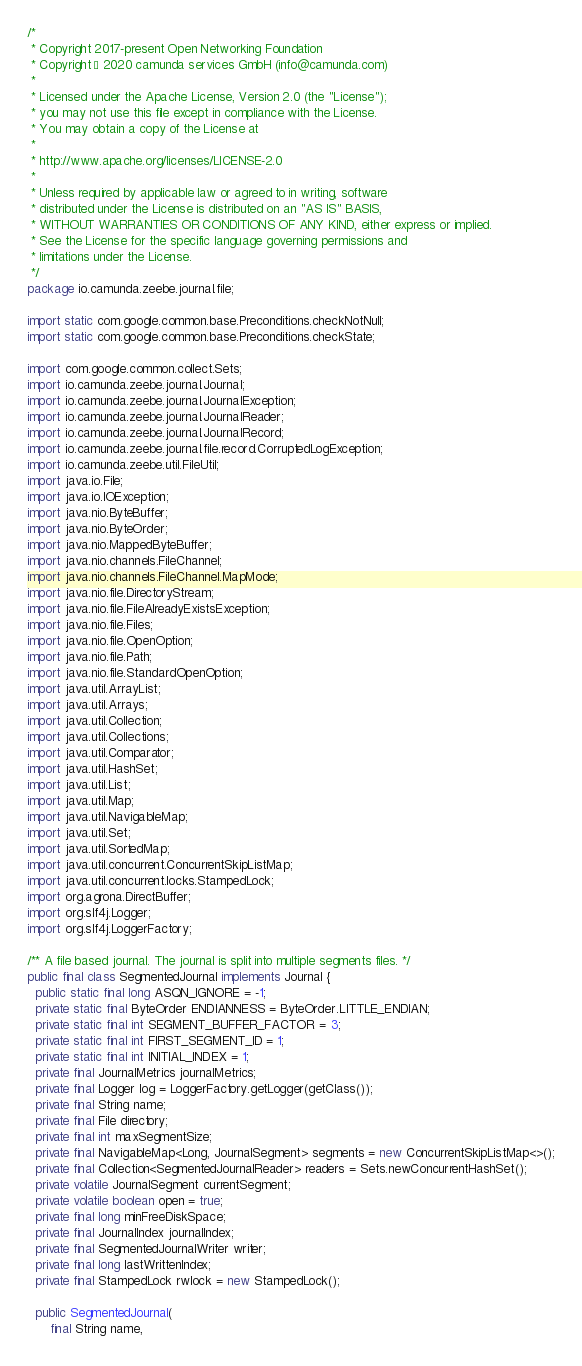<code> <loc_0><loc_0><loc_500><loc_500><_Java_>/*
 * Copyright 2017-present Open Networking Foundation
 * Copyright © 2020 camunda services GmbH (info@camunda.com)
 *
 * Licensed under the Apache License, Version 2.0 (the "License");
 * you may not use this file except in compliance with the License.
 * You may obtain a copy of the License at
 *
 * http://www.apache.org/licenses/LICENSE-2.0
 *
 * Unless required by applicable law or agreed to in writing, software
 * distributed under the License is distributed on an "AS IS" BASIS,
 * WITHOUT WARRANTIES OR CONDITIONS OF ANY KIND, either express or implied.
 * See the License for the specific language governing permissions and
 * limitations under the License.
 */
package io.camunda.zeebe.journal.file;

import static com.google.common.base.Preconditions.checkNotNull;
import static com.google.common.base.Preconditions.checkState;

import com.google.common.collect.Sets;
import io.camunda.zeebe.journal.Journal;
import io.camunda.zeebe.journal.JournalException;
import io.camunda.zeebe.journal.JournalReader;
import io.camunda.zeebe.journal.JournalRecord;
import io.camunda.zeebe.journal.file.record.CorruptedLogException;
import io.camunda.zeebe.util.FileUtil;
import java.io.File;
import java.io.IOException;
import java.nio.ByteBuffer;
import java.nio.ByteOrder;
import java.nio.MappedByteBuffer;
import java.nio.channels.FileChannel;
import java.nio.channels.FileChannel.MapMode;
import java.nio.file.DirectoryStream;
import java.nio.file.FileAlreadyExistsException;
import java.nio.file.Files;
import java.nio.file.OpenOption;
import java.nio.file.Path;
import java.nio.file.StandardOpenOption;
import java.util.ArrayList;
import java.util.Arrays;
import java.util.Collection;
import java.util.Collections;
import java.util.Comparator;
import java.util.HashSet;
import java.util.List;
import java.util.Map;
import java.util.NavigableMap;
import java.util.Set;
import java.util.SortedMap;
import java.util.concurrent.ConcurrentSkipListMap;
import java.util.concurrent.locks.StampedLock;
import org.agrona.DirectBuffer;
import org.slf4j.Logger;
import org.slf4j.LoggerFactory;

/** A file based journal. The journal is split into multiple segments files. */
public final class SegmentedJournal implements Journal {
  public static final long ASQN_IGNORE = -1;
  private static final ByteOrder ENDIANNESS = ByteOrder.LITTLE_ENDIAN;
  private static final int SEGMENT_BUFFER_FACTOR = 3;
  private static final int FIRST_SEGMENT_ID = 1;
  private static final int INITIAL_INDEX = 1;
  private final JournalMetrics journalMetrics;
  private final Logger log = LoggerFactory.getLogger(getClass());
  private final String name;
  private final File directory;
  private final int maxSegmentSize;
  private final NavigableMap<Long, JournalSegment> segments = new ConcurrentSkipListMap<>();
  private final Collection<SegmentedJournalReader> readers = Sets.newConcurrentHashSet();
  private volatile JournalSegment currentSegment;
  private volatile boolean open = true;
  private final long minFreeDiskSpace;
  private final JournalIndex journalIndex;
  private final SegmentedJournalWriter writer;
  private final long lastWrittenIndex;
  private final StampedLock rwlock = new StampedLock();

  public SegmentedJournal(
      final String name,</code> 